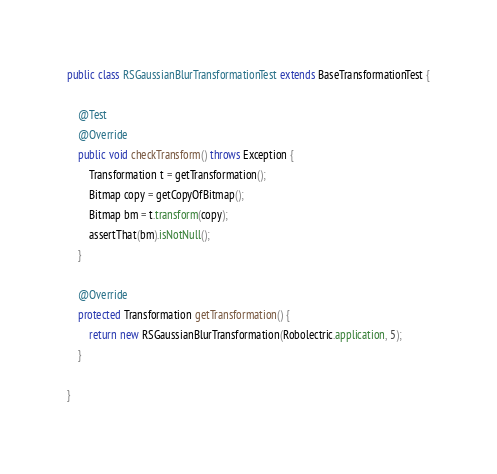<code> <loc_0><loc_0><loc_500><loc_500><_Java_>
public class RSGaussianBlurTransformationTest extends BaseTransformationTest {

    @Test
    @Override
    public void checkTransform() throws Exception {
        Transformation t = getTransformation();
        Bitmap copy = getCopyOfBitmap();
        Bitmap bm = t.transform(copy);
        assertThat(bm).isNotNull();
    }
    
    @Override
    protected Transformation getTransformation() {
        return new RSGaussianBlurTransformation(Robolectric.application, 5);
    }

}
</code> 